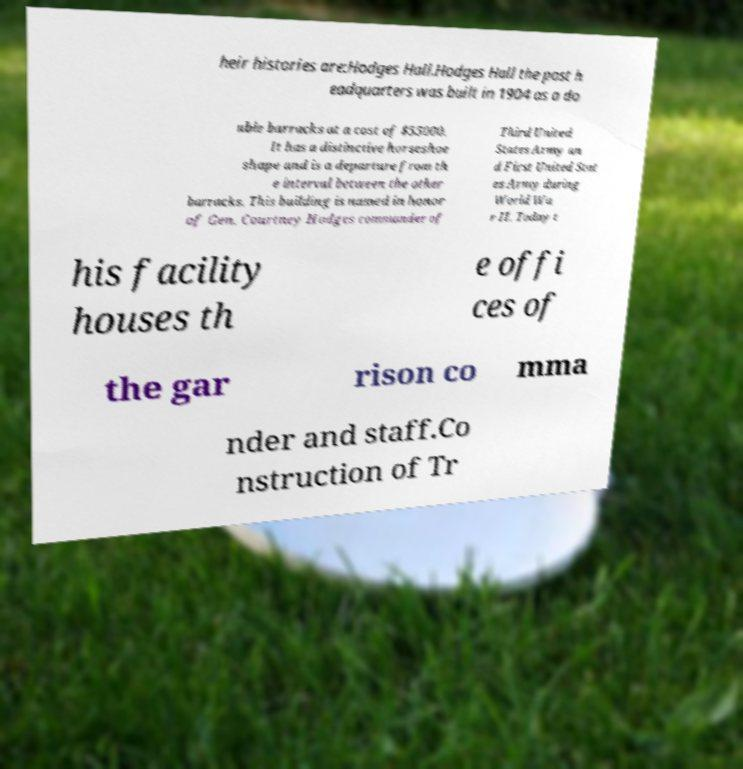Could you assist in decoding the text presented in this image and type it out clearly? heir histories are:Hodges Hall.Hodges Hall the post h eadquarters was built in 1904 as a do uble barracks at a cost of $55000. It has a distinctive horseshoe shape and is a departure from th e interval between the other barracks. This building is named in honor of Gen. Courtney Hodges commander of Third United States Army an d First United Stat es Army during World Wa r II. Today t his facility houses th e offi ces of the gar rison co mma nder and staff.Co nstruction of Tr 